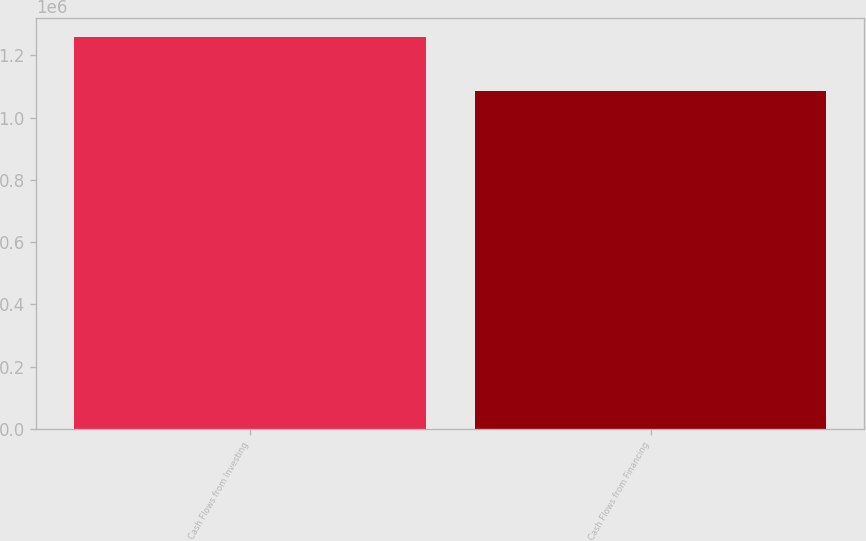<chart> <loc_0><loc_0><loc_500><loc_500><bar_chart><fcel>Cash Flows from Investing<fcel>Cash Flows from Financing<nl><fcel>1.25893e+06<fcel>1.08504e+06<nl></chart> 